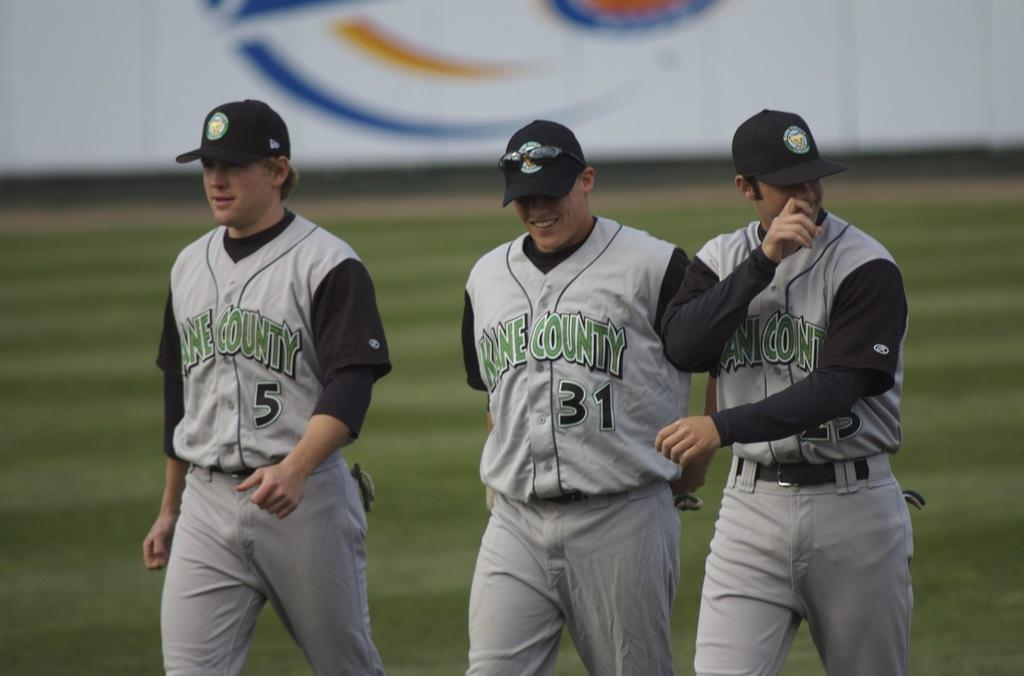<image>
Give a short and clear explanation of the subsequent image. Three men wearing Kane County baseball uniforms on a baseball field. 